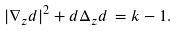Convert formula to latex. <formula><loc_0><loc_0><loc_500><loc_500>| \nabla _ { z } d | ^ { 2 } + d \Delta _ { z } d \, = k - 1 .</formula> 